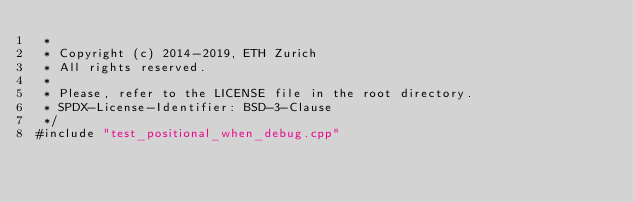Convert code to text. <code><loc_0><loc_0><loc_500><loc_500><_Cuda_> *
 * Copyright (c) 2014-2019, ETH Zurich
 * All rights reserved.
 *
 * Please, refer to the LICENSE file in the root directory.
 * SPDX-License-Identifier: BSD-3-Clause
 */
#include "test_positional_when_debug.cpp"
</code> 